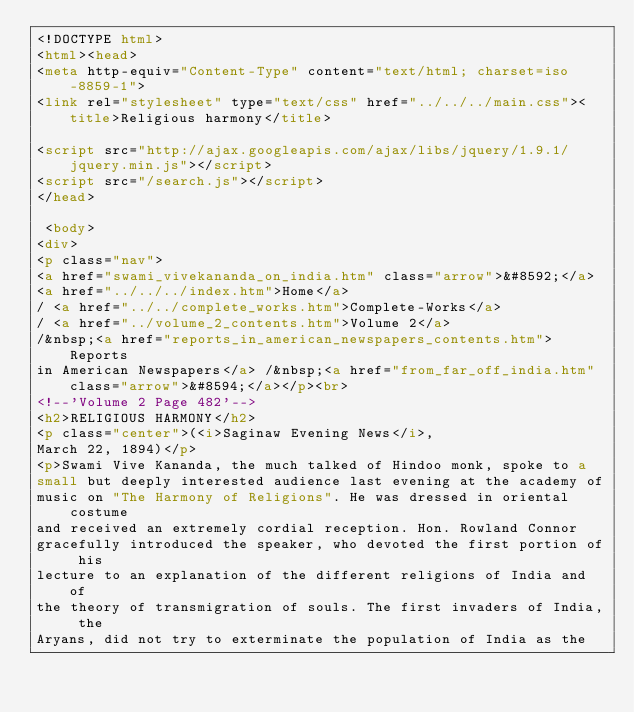Convert code to text. <code><loc_0><loc_0><loc_500><loc_500><_HTML_><!DOCTYPE html>
<html><head>
<meta http-equiv="Content-Type" content="text/html; charset=iso-8859-1">
<link rel="stylesheet" type="text/css" href="../../../main.css"><title>Religious harmony</title>

<script src="http://ajax.googleapis.com/ajax/libs/jquery/1.9.1/jquery.min.js"></script>
<script src="/search.js"></script>
</head>

 <body>
<div>
<p class="nav">
<a href="swami_vivekananda_on_india.htm" class="arrow">&#8592;</a>
<a href="../../../index.htm">Home</a>
/ <a href="../../complete_works.htm">Complete-Works</a>
/ <a href="../volume_2_contents.htm">Volume 2</a>
/&nbsp;<a href="reports_in_american_newspapers_contents.htm">Reports
in American Newspapers</a> /&nbsp;<a href="from_far_off_india.htm" class="arrow">&#8594;</a></p><br>
<!--'Volume 2 Page 482'-->
<h2>RELIGIOUS HARMONY</h2>
<p class="center">(<i>Saginaw Evening News</i>,
March 22, 1894)</p>
<p>Swami Vive Kananda, the much talked of Hindoo monk, spoke to a
small but deeply interested audience last evening at the academy of
music on "The Harmony of Religions". He was dressed in oriental costume
and received an extremely cordial reception. Hon. Rowland Connor
gracefully introduced the speaker, who devoted the first portion of his
lecture to an explanation of the different religions of India and of
the theory of transmigration of souls. The first invaders of India, the
Aryans, did not try to exterminate the population of India as the</code> 